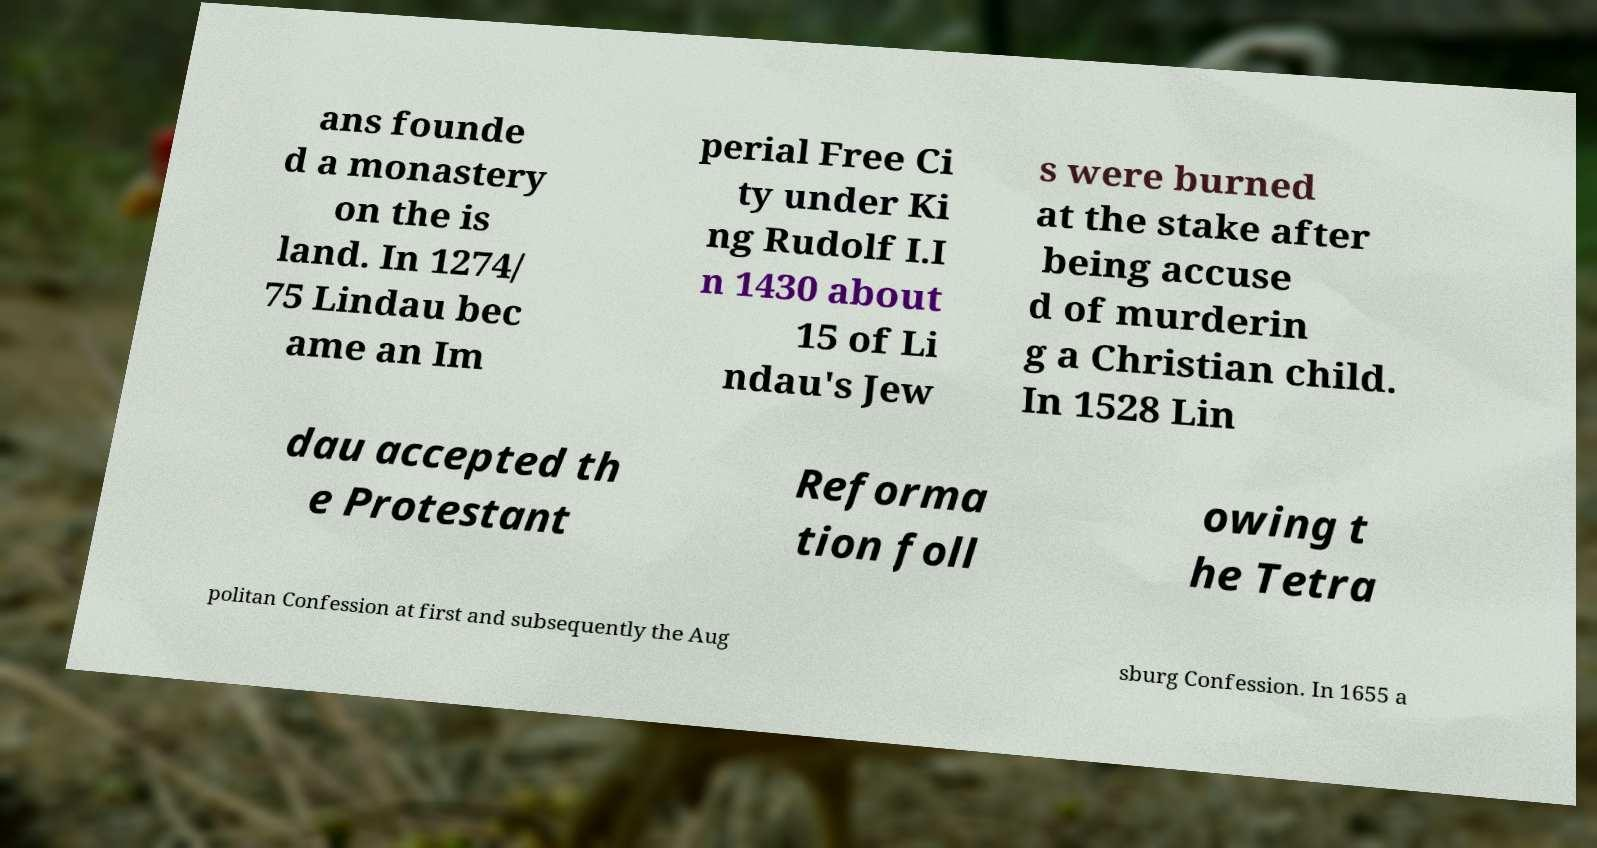Can you read and provide the text displayed in the image?This photo seems to have some interesting text. Can you extract and type it out for me? ans founde d a monastery on the is land. In 1274/ 75 Lindau bec ame an Im perial Free Ci ty under Ki ng Rudolf I.I n 1430 about 15 of Li ndau's Jew s were burned at the stake after being accuse d of murderin g a Christian child. In 1528 Lin dau accepted th e Protestant Reforma tion foll owing t he Tetra politan Confession at first and subsequently the Aug sburg Confession. In 1655 a 